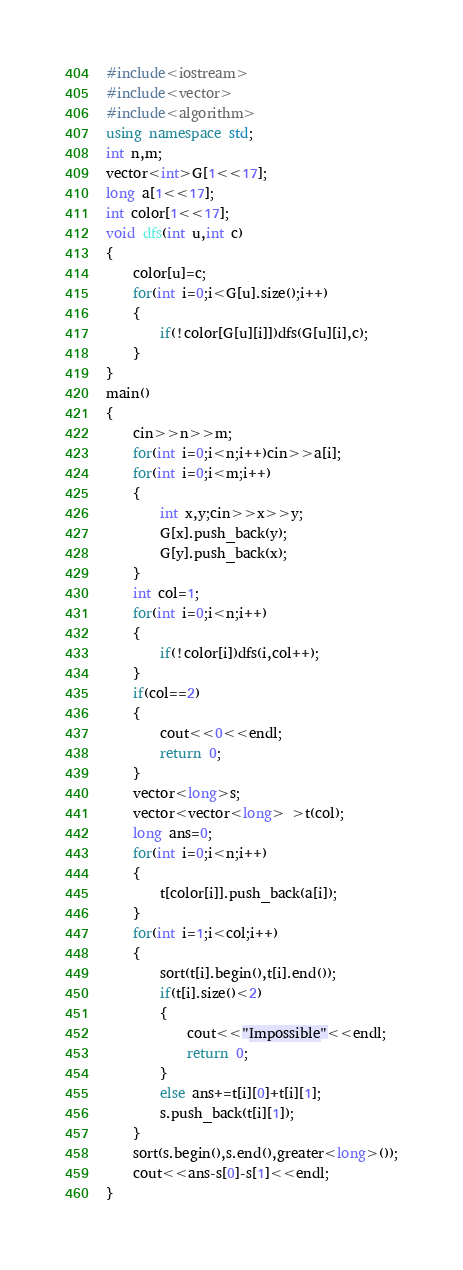Convert code to text. <code><loc_0><loc_0><loc_500><loc_500><_C++_>#include<iostream>
#include<vector>
#include<algorithm>
using namespace std;
int n,m;
vector<int>G[1<<17];
long a[1<<17];
int color[1<<17];
void dfs(int u,int c)
{
	color[u]=c;
	for(int i=0;i<G[u].size();i++)
	{
		if(!color[G[u][i]])dfs(G[u][i],c);
	}
}
main()
{
	cin>>n>>m;
	for(int i=0;i<n;i++)cin>>a[i];
	for(int i=0;i<m;i++)
	{
		int x,y;cin>>x>>y;
		G[x].push_back(y);
		G[y].push_back(x);
	}
	int col=1;
	for(int i=0;i<n;i++)
	{
		if(!color[i])dfs(i,col++);
	}
	if(col==2)
	{
		cout<<0<<endl;
		return 0;
	}
	vector<long>s;
	vector<vector<long> >t(col);
	long ans=0;
	for(int i=0;i<n;i++)
	{
		t[color[i]].push_back(a[i]);
	}
	for(int i=1;i<col;i++)
	{
		sort(t[i].begin(),t[i].end());
		if(t[i].size()<2)
		{
			cout<<"Impossible"<<endl;
			return 0;
		}
		else ans+=t[i][0]+t[i][1];
		s.push_back(t[i][1]);
	}
	sort(s.begin(),s.end(),greater<long>());
	cout<<ans-s[0]-s[1]<<endl;
}
</code> 